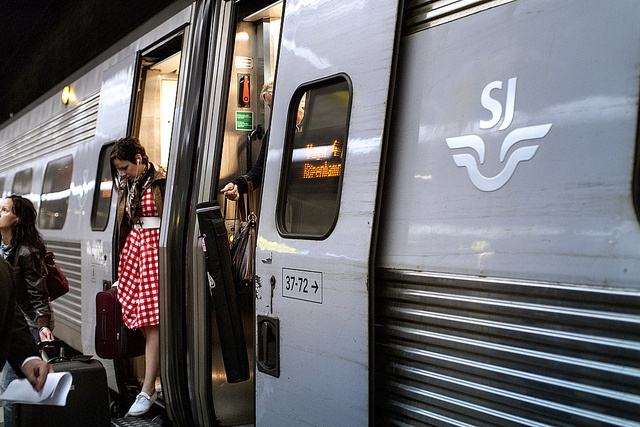Describe the objects in this image and their specific colors. I can see train in darkgray, black, lightgray, and gray tones, people in black, brown, maroon, and lavender tones, people in black, gray, and maroon tones, suitcase in black, gray, darkgray, and lightgray tones, and people in black, maroon, and gray tones in this image. 